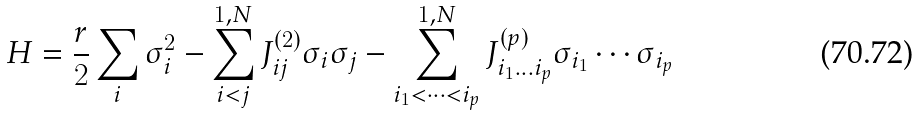Convert formula to latex. <formula><loc_0><loc_0><loc_500><loc_500>H = \frac { r } { 2 } \sum _ { i } \sigma _ { i } ^ { 2 } - \sum _ { i < j } ^ { 1 , N } J ^ { ( 2 ) } _ { i j } \sigma _ { i } \sigma _ { j } - \sum _ { i _ { 1 } < \dots < i _ { p } } ^ { 1 , N } J ^ { ( p ) } _ { i _ { 1 } \dots i _ { p } } \sigma _ { i _ { 1 } } \cdots \sigma _ { i _ { p } }</formula> 